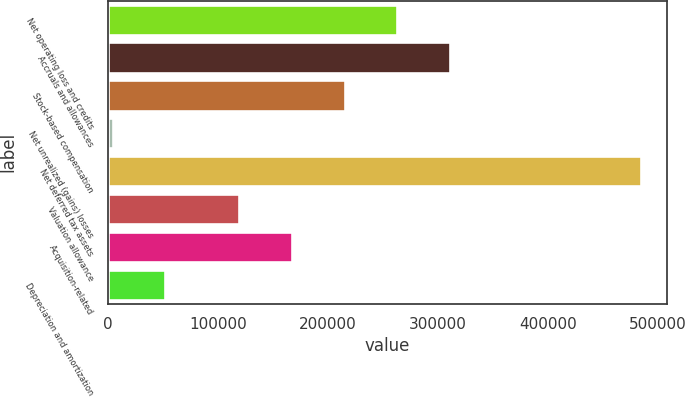Convert chart. <chart><loc_0><loc_0><loc_500><loc_500><bar_chart><fcel>Net operating loss and credits<fcel>Accruals and allowances<fcel>Stock-based compensation<fcel>Net unrealized (gains) losses<fcel>Net deferred tax assets<fcel>Valuation allowance<fcel>Acquisition-related<fcel>Depreciation and amortization<nl><fcel>263233<fcel>311259<fcel>215206<fcel>4145<fcel>484411<fcel>119153<fcel>167180<fcel>52171.6<nl></chart> 